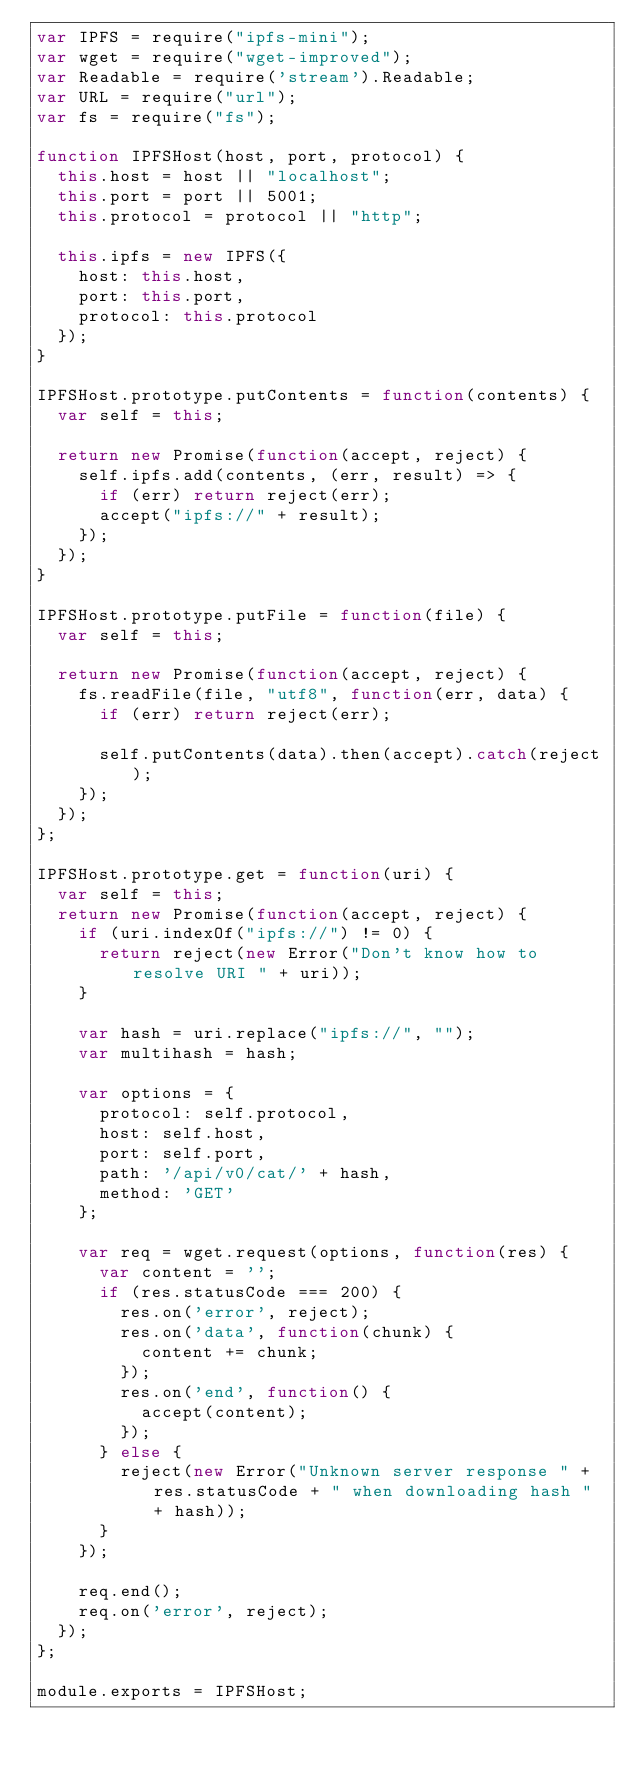Convert code to text. <code><loc_0><loc_0><loc_500><loc_500><_JavaScript_>var IPFS = require("ipfs-mini");
var wget = require("wget-improved");
var Readable = require('stream').Readable;
var URL = require("url");
var fs = require("fs");

function IPFSHost(host, port, protocol) {
  this.host = host || "localhost";
  this.port = port || 5001;
  this.protocol = protocol || "http";

  this.ipfs = new IPFS({
    host: this.host,
    port: this.port,
    protocol: this.protocol
  });
}

IPFSHost.prototype.putContents = function(contents) {
  var self = this;

  return new Promise(function(accept, reject) {
    self.ipfs.add(contents, (err, result) => {
      if (err) return reject(err);
      accept("ipfs://" + result);
    });
  });
}

IPFSHost.prototype.putFile = function(file) {
  var self = this;

  return new Promise(function(accept, reject) {
    fs.readFile(file, "utf8", function(err, data) {
      if (err) return reject(err);

      self.putContents(data).then(accept).catch(reject);
    });
  });
};

IPFSHost.prototype.get = function(uri) {
  var self = this;
  return new Promise(function(accept, reject) {
    if (uri.indexOf("ipfs://") != 0) {
      return reject(new Error("Don't know how to resolve URI " + uri));
    }

    var hash = uri.replace("ipfs://", "");
    var multihash = hash;

    var options = {
      protocol: self.protocol,
      host: self.host,
      port: self.port,
      path: '/api/v0/cat/' + hash,
      method: 'GET'
    };

    var req = wget.request(options, function(res) {
      var content = '';
      if (res.statusCode === 200) {
        res.on('error', reject);
        res.on('data', function(chunk) {
          content += chunk;
        });
        res.on('end', function() {
          accept(content);
        });
      } else {
        reject(new Error("Unknown server response " + res.statusCode + " when downloading hash " + hash));
      }
    });

    req.end();
    req.on('error', reject);
  });
};

module.exports = IPFSHost;
</code> 